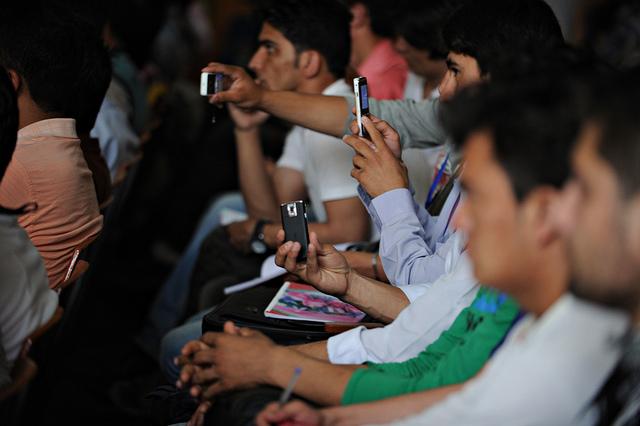How many people have cell phones?
Give a very brief answer. 3. Are these people using technology?
Be succinct. Yes. What is the man in the red and white cap doing?
Be succinct. Filming. Is a pen being held?
Short answer required. Yes. How many people are having a conversation in the scene?
Keep it brief. 0. What are the men holding onto?
Write a very short answer. Phones. Are the people sitting?
Concise answer only. Yes. 